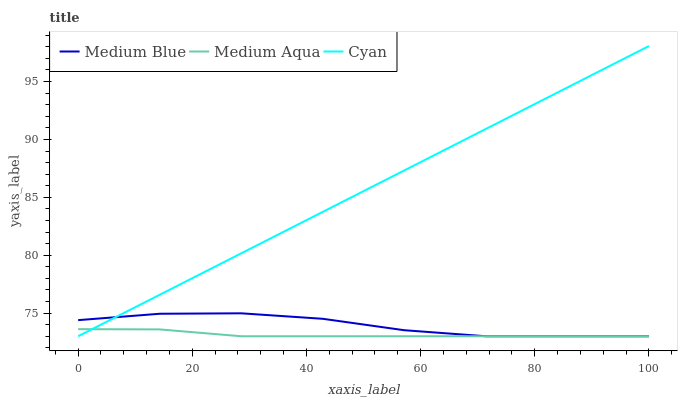Does Medium Aqua have the minimum area under the curve?
Answer yes or no. Yes. Does Cyan have the maximum area under the curve?
Answer yes or no. Yes. Does Medium Blue have the minimum area under the curve?
Answer yes or no. No. Does Medium Blue have the maximum area under the curve?
Answer yes or no. No. Is Cyan the smoothest?
Answer yes or no. Yes. Is Medium Blue the roughest?
Answer yes or no. Yes. Is Medium Blue the smoothest?
Answer yes or no. No. Is Cyan the roughest?
Answer yes or no. No. Does Medium Aqua have the lowest value?
Answer yes or no. Yes. Does Cyan have the highest value?
Answer yes or no. Yes. Does Medium Blue have the highest value?
Answer yes or no. No. Does Medium Blue intersect Medium Aqua?
Answer yes or no. Yes. Is Medium Blue less than Medium Aqua?
Answer yes or no. No. Is Medium Blue greater than Medium Aqua?
Answer yes or no. No. 